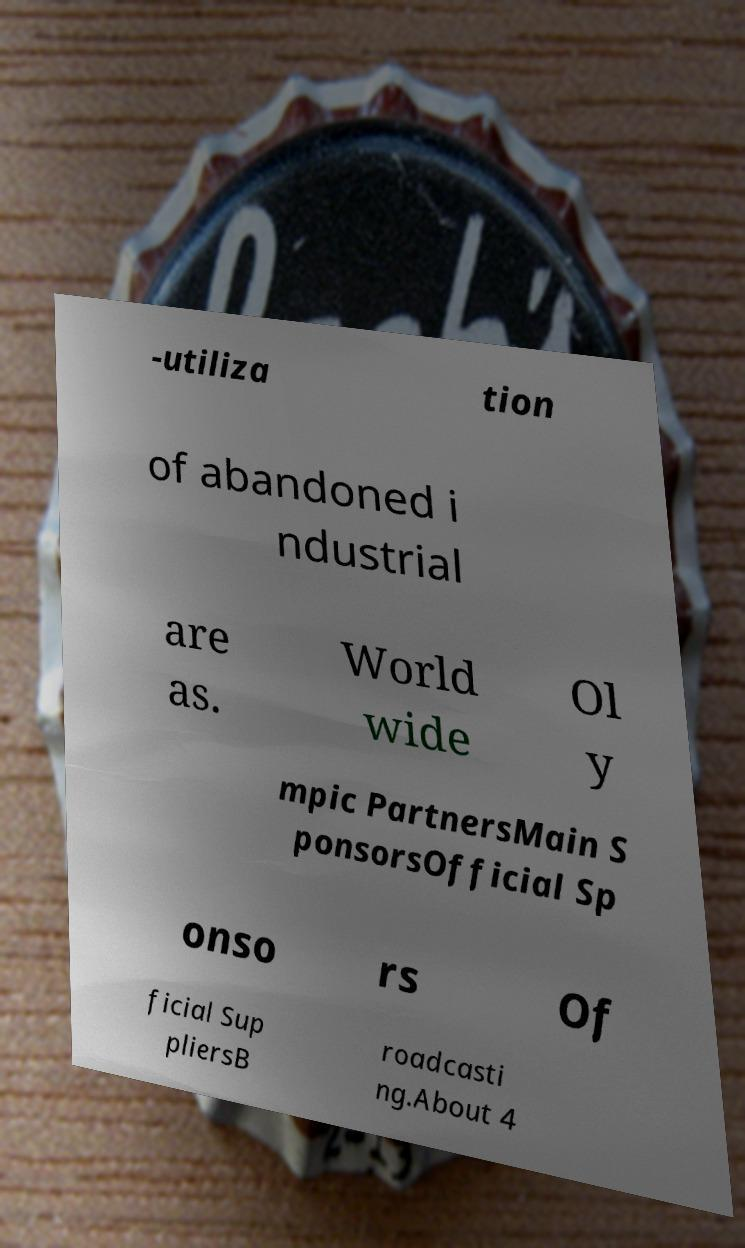Can you read and provide the text displayed in the image?This photo seems to have some interesting text. Can you extract and type it out for me? -utiliza tion of abandoned i ndustrial are as. World wide Ol y mpic PartnersMain S ponsorsOfficial Sp onso rs Of ficial Sup pliersB roadcasti ng.About 4 